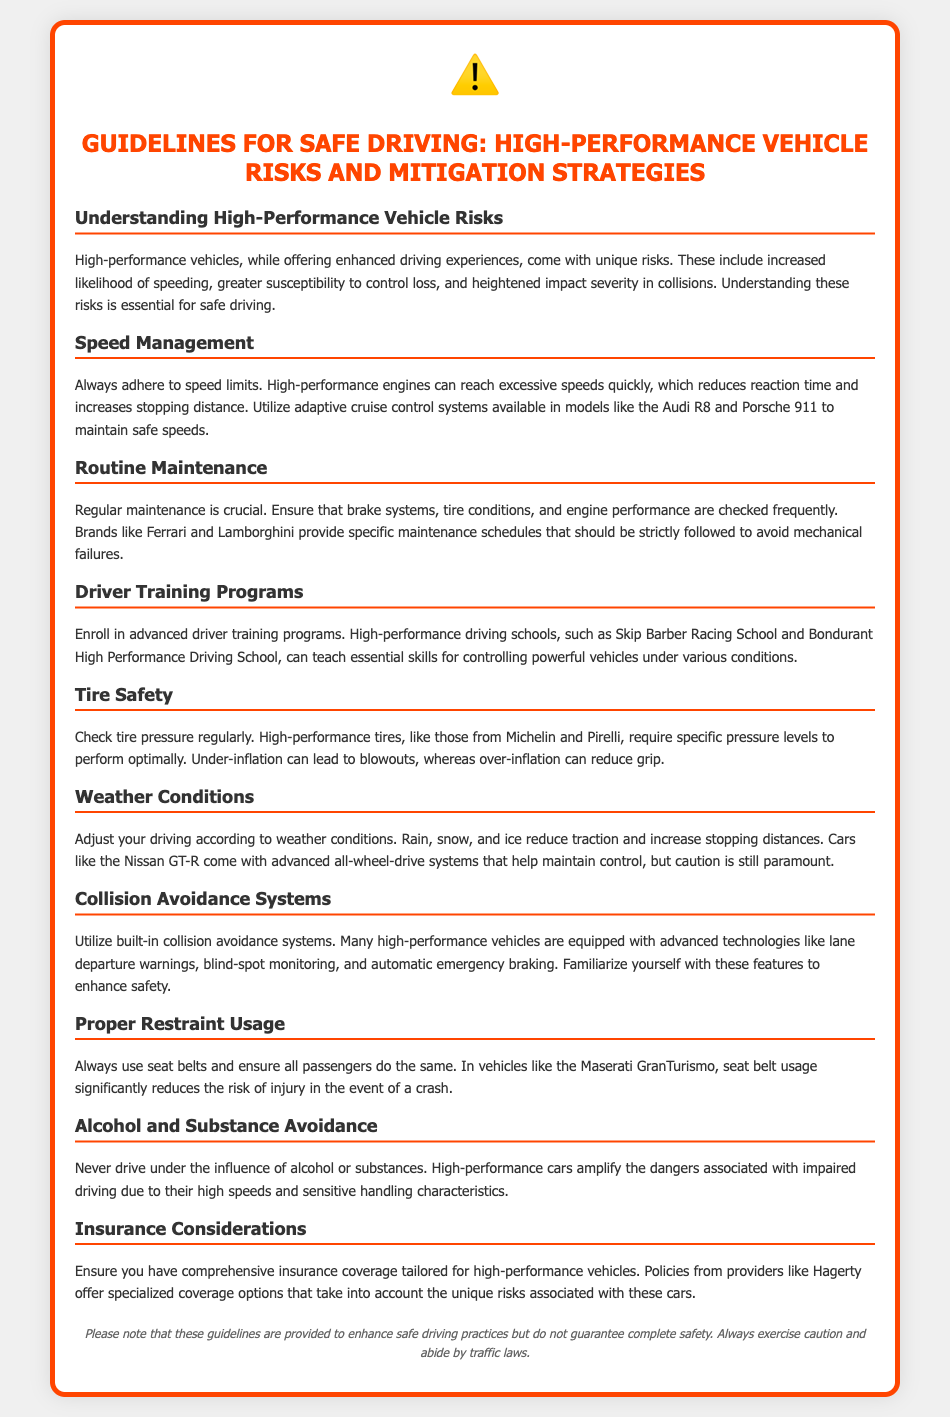What are the unique risks associated with high-performance vehicles? The unique risks include increased likelihood of speeding, greater susceptibility to control loss, and heightened impact severity in collisions.
Answer: Increased likelihood of speeding, greater susceptibility to control loss, heightened impact severity in collisions What should be checked regularly for safe driving? Regular maintenance is crucial including checking brake systems, tire conditions, and engine performance.
Answer: Brake systems, tire conditions, engine performance What is an example of a driving school for advanced training? The document mentions Skip Barber Racing School and Bondurant High Performance Driving School as examples of such schools.
Answer: Skip Barber Racing School What does under-inflation of high-performance tires lead to? Under-inflation can lead to blowouts, as per the tire safety guidelines.
Answer: Blowouts Which vehicle feature helps maintain control in bad weather? Advanced all-wheel-drive systems, mentioned in the context of the Nissan GT-R, help maintain control.
Answer: Advanced all-wheel-drive systems What is a critical aspect of driver safety mentioned in the document? Always using seat belts and ensuring that all passengers do the same is a critical safety aspect.
Answer: Seat belts What factor increases stopping distances in bad weather? Rain, snow, and ice are mentioned as conditions that increase stopping distances.
Answer: Rain, snow, and ice What type of insurance is recommended for high-performance vehicles? Comprehensive insurance coverage tailored for high-performance vehicles is recommended, with policies from providers like Hagerty.
Answer: Comprehensive insurance coverage What safety feature should drivers familiarize themselves with? Familiarizing oneself with built-in collision avoidance systems is advised for enhancing safety.
Answer: Built-in collision avoidance systems 